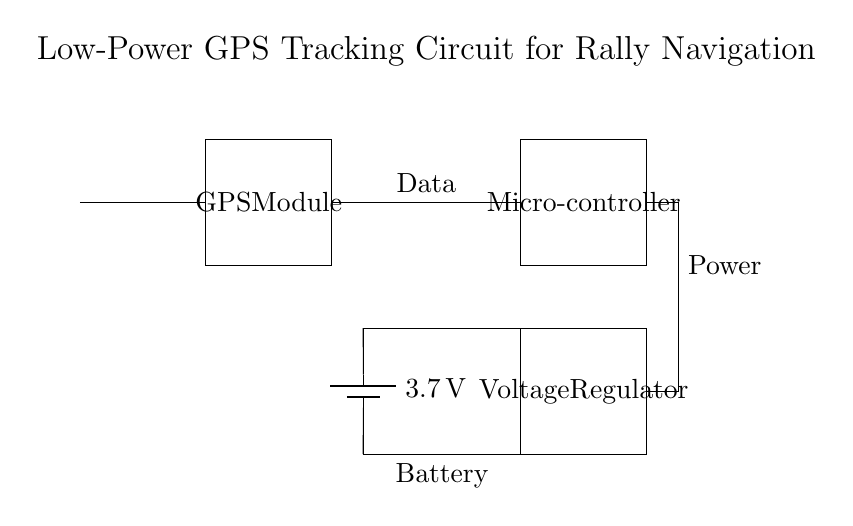What component provides power to the circuit? The circuit includes a battery, which is indicated as providing a voltage of 3.7 volts. This battery connects to the voltage regulator and other components to power them.
Answer: battery What is the function of the microcontroller in this circuit? The microcontroller processes the data received from the GPS module and manages the overall functioning of the circuit. It orchestrates the communication and operations while consuming low power.
Answer: data processing What is the voltage rating of the battery? The battery in the circuit is rated at 3.7 volts, as labeled directly on the battery symbol in the diagram.
Answer: 3.7 volts How does the GPS module receive signals? The GPS module receives signals through an antenna, which is connected directly to it, allowing it to pick up satellite signals for navigation.
Answer: antenna What component regulates the voltage for the circuit? The voltage regulator is responsible for ensuring that the components receive a steady voltage from the battery, adjusting as necessary to maintain a consistent output.
Answer: voltage regulator What are the connections between the GPS module and the microcontroller? The GPS module is connected to the microcontroller via a data connection, which allows the microcontroller to receive location data from the module, enabling rally navigation functionality.
Answer: data connection 